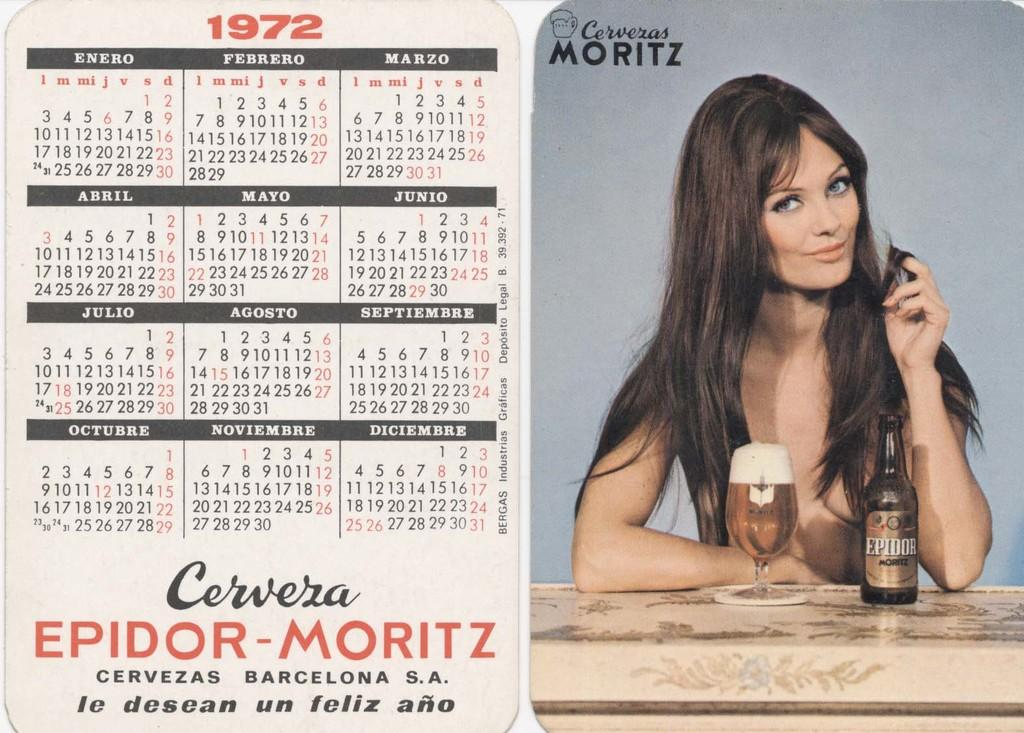What is the main object in the image? There is a calendar in the image. What can be found on the calendar? The calendar has some text on it. Is there any representation of a person in the image? Yes, there is a picture of a person in the image. What other objects can be seen in the image? There is a bottle and a glass in the image. Is there any text visible on the right side of the image? Yes, there is some text on the right side of the image. Can you see a plough in the image? No, there is no plough present in the image. 